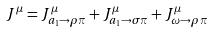<formula> <loc_0><loc_0><loc_500><loc_500>J ^ { \mu } = J _ { a _ { 1 } \rightarrow \rho \pi } ^ { \mu } + J _ { a _ { 1 } \rightarrow \sigma \pi } ^ { \mu } + J _ { \omega \rightarrow \rho \pi } ^ { \mu }</formula> 